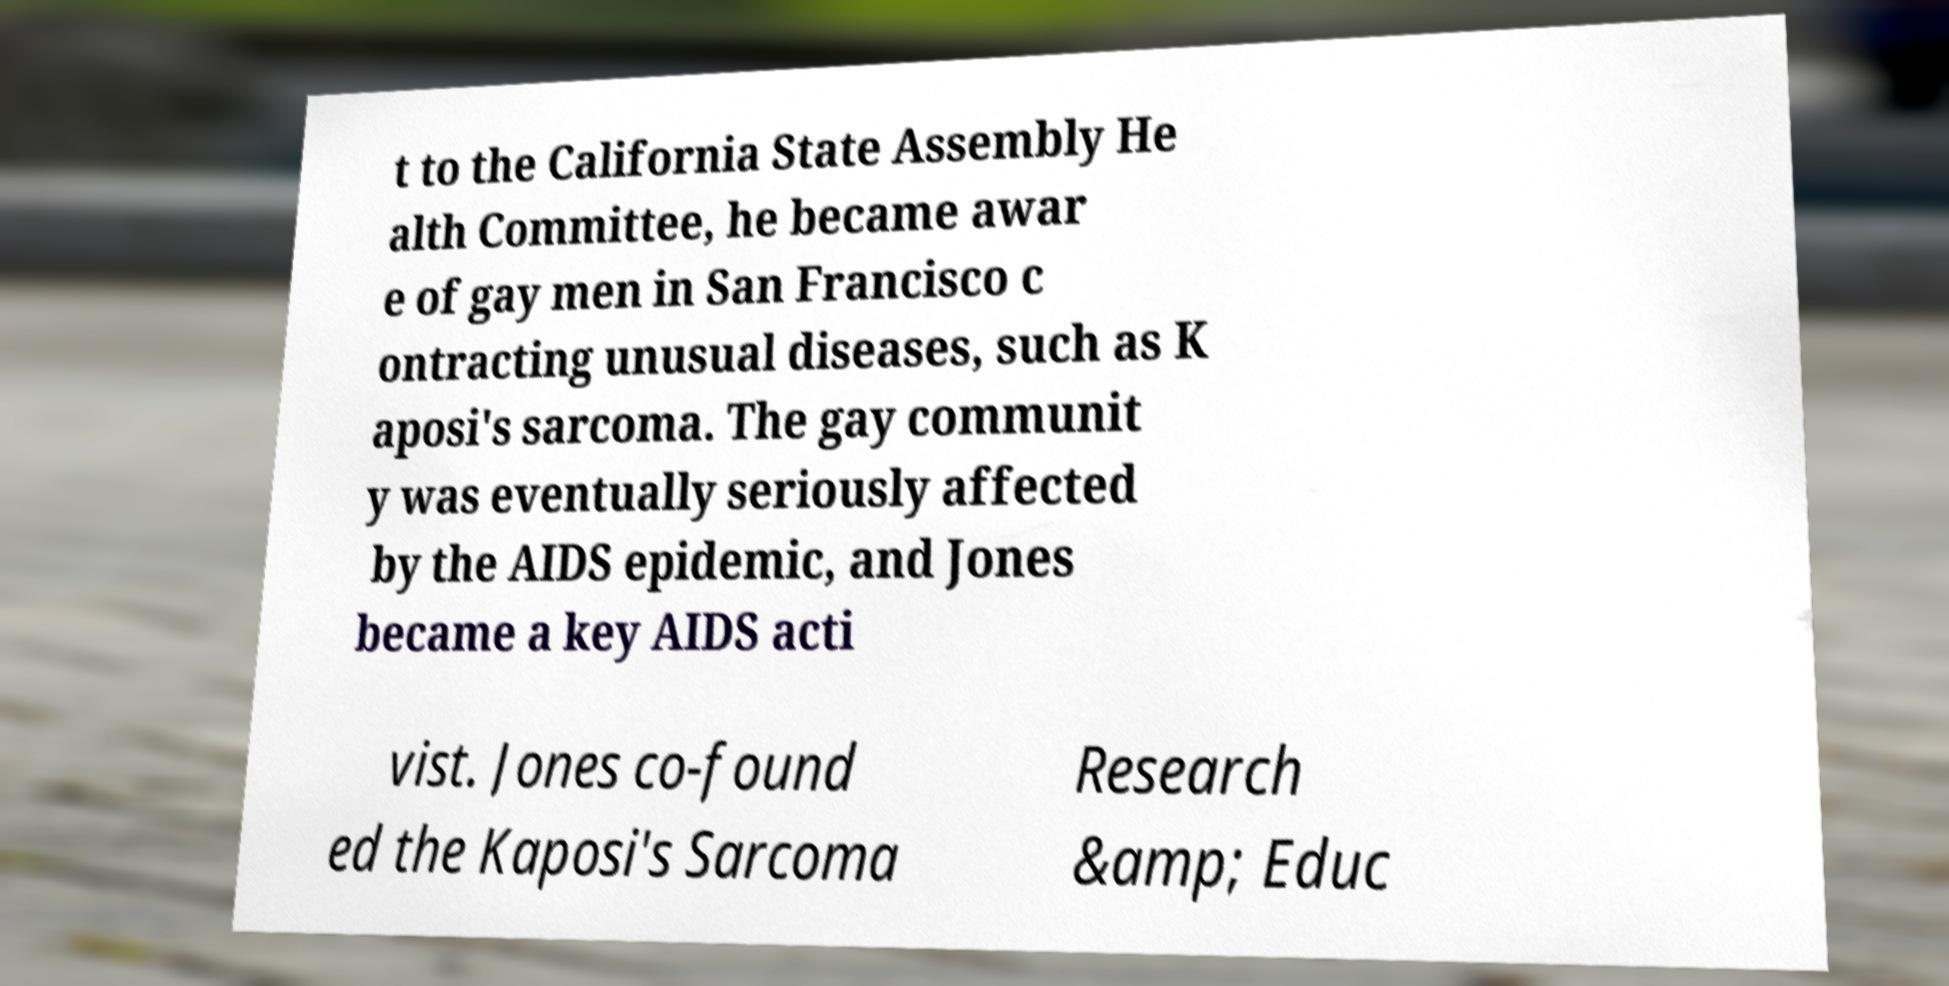Could you extract and type out the text from this image? t to the California State Assembly He alth Committee, he became awar e of gay men in San Francisco c ontracting unusual diseases, such as K aposi's sarcoma. The gay communit y was eventually seriously affected by the AIDS epidemic, and Jones became a key AIDS acti vist. Jones co-found ed the Kaposi's Sarcoma Research &amp; Educ 